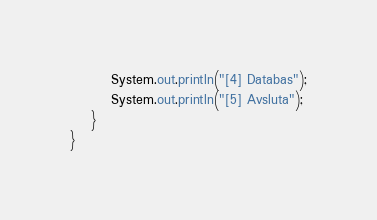Convert code to text. <code><loc_0><loc_0><loc_500><loc_500><_Java_>        System.out.println("[4] Databas");
        System.out.println("[5] Avsluta");
    }
}
</code> 